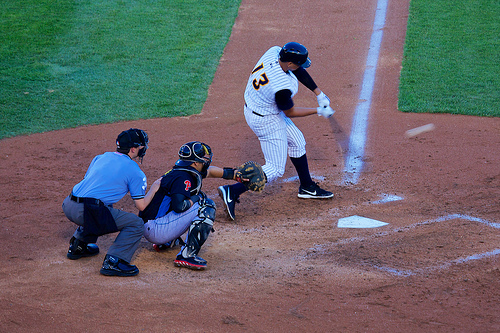Are there umpires behind the person the ball is to the right of? Yes, there are two umpires positioned behind the catcher, near the person who is to the right of the ball. 